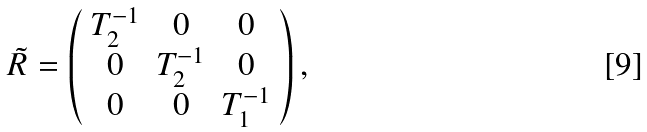<formula> <loc_0><loc_0><loc_500><loc_500>\tilde { R } = \left ( \begin{array} { c c c } T _ { 2 } ^ { - 1 } & 0 & 0 \\ 0 & T _ { 2 } ^ { - 1 } & 0 \\ 0 & 0 & T _ { 1 } ^ { - 1 } \end{array} \right ) ,</formula> 